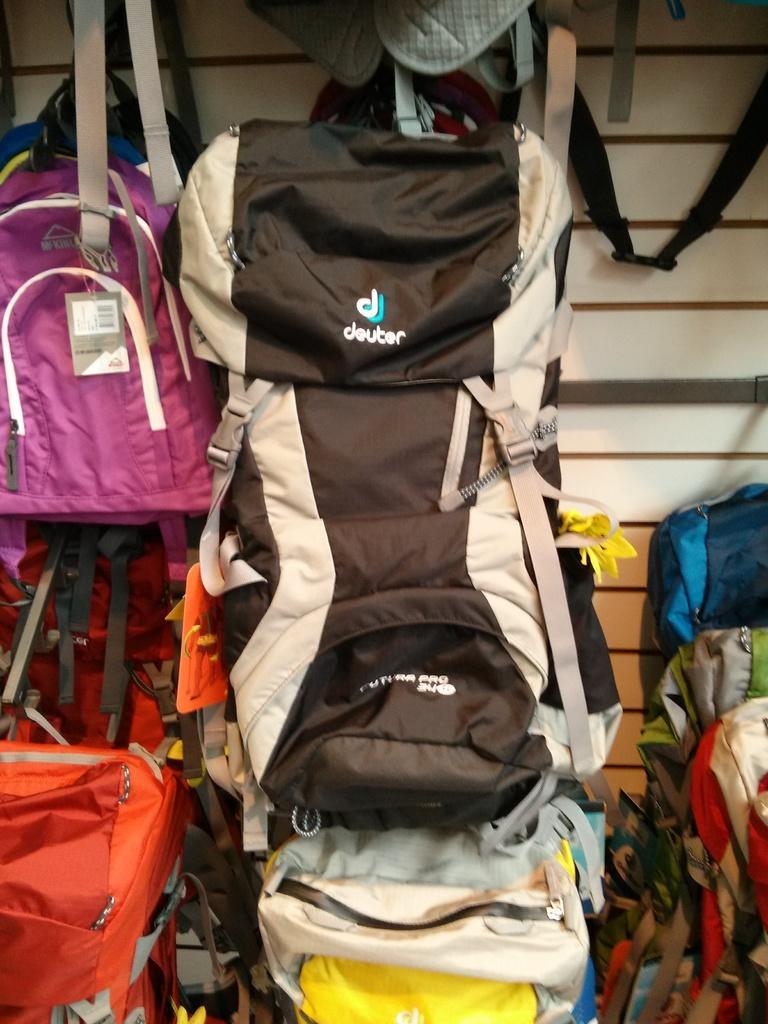Could you give a brief overview of what you see in this image? As we can see in the image there are few bags with different colors. 